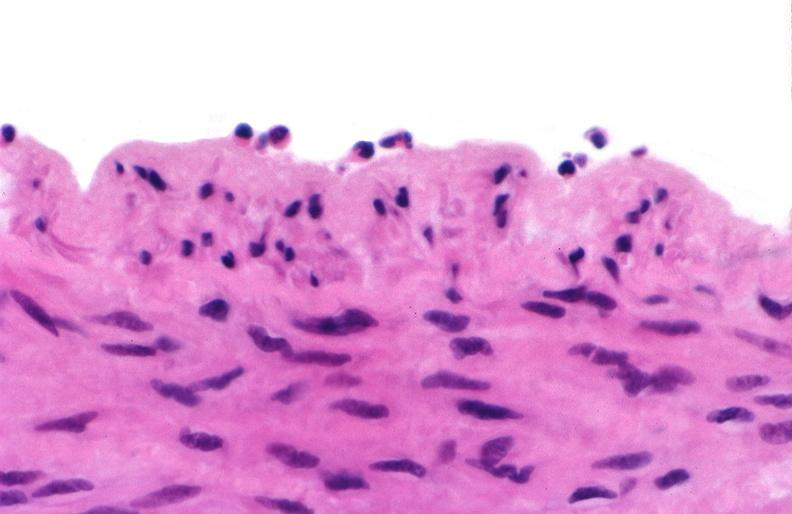s this photo of infant from head to toe present?
Answer the question using a single word or phrase. No 